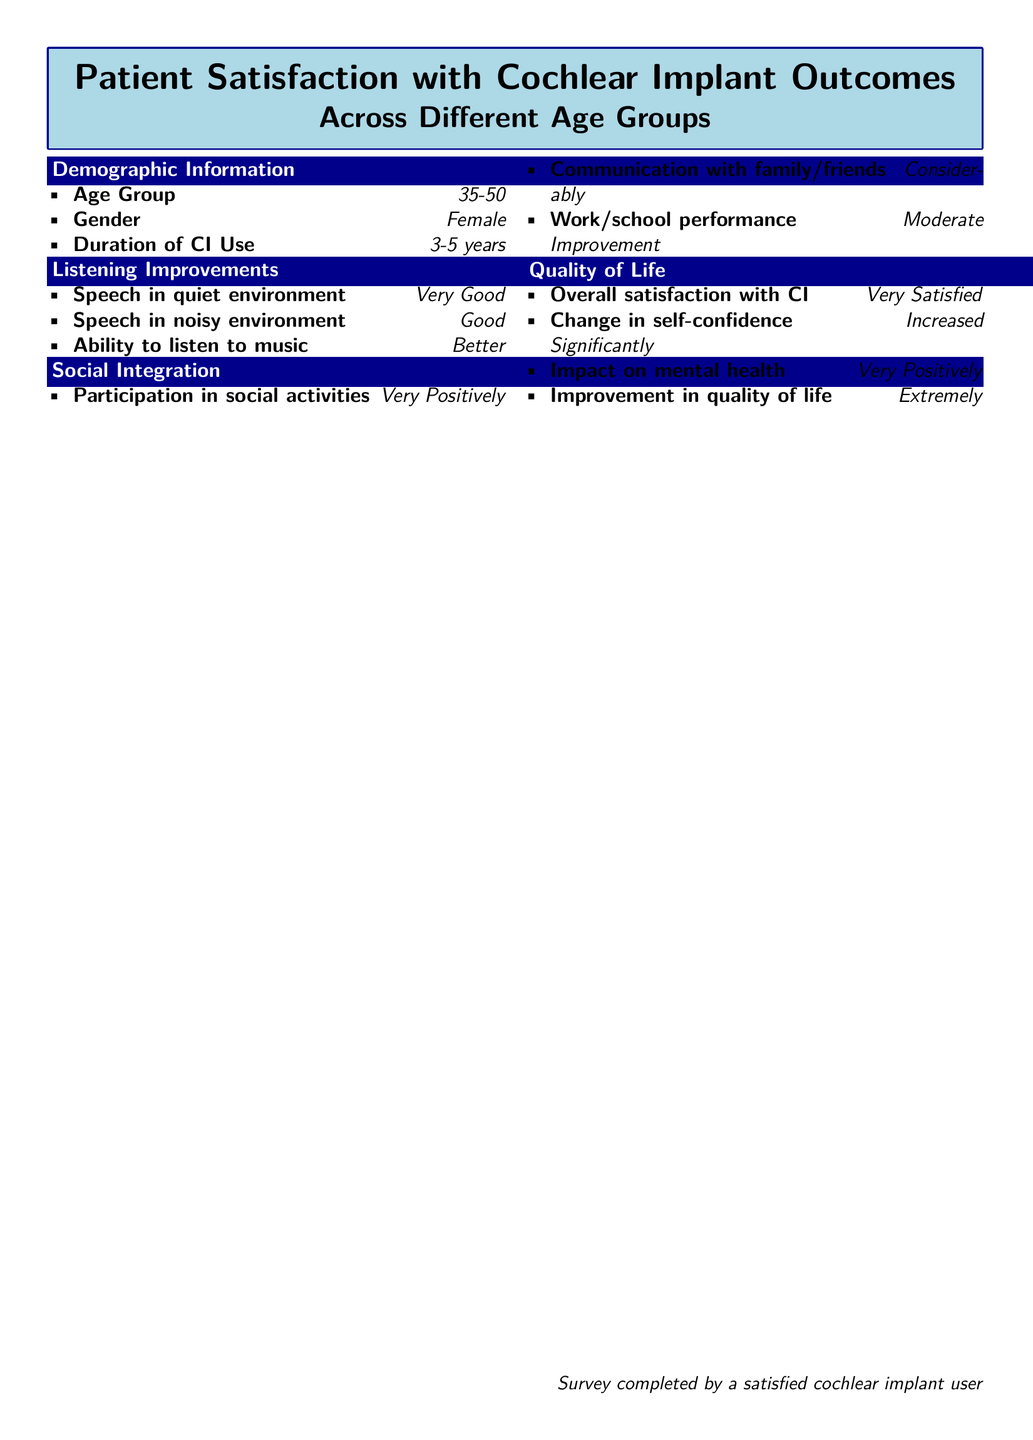What age group does the respondent fall into? The document indicates the age group of the respondent under Demographic Information.
Answer: 35-50 How long has the respondent been using the cochlear implant? The duration of cochlear implant use is listed in the Demographic Information section.
Answer: 3-5 years What is the respondent's satisfaction level with their cochlear implant? The level of overall satisfaction is explicitly mentioned in the Quality of Life section.
Answer: Very Satisfied How does the respondent feel their self-confidence has changed? The change in self-confidence is described in the Quality of Life section.
Answer: Increased Significantly What is the respondent's assessment of their ability to listen to music after the cochlear implant? The respondent's ability to listen to music is detailed in the Listening Improvements section.
Answer: Better What impact has the cochlear implant had on the respondent's mental health? The effect of the cochlear implant on mental health is noted in the Quality of Life section.
Answer: Very Positively In which environment does the respondent report very good speech understanding? The specific environment for speech understanding is mentioned under Listening Improvements.
Answer: quiet environment How does the respondent rate their communication with family and friends? The rating of communication is found in the Social Integration section.
Answer: Considerably What is the reported improvement level in the respondent's work or school performance? The document lists this information under Social Integration.
Answer: Moderate Improvement 